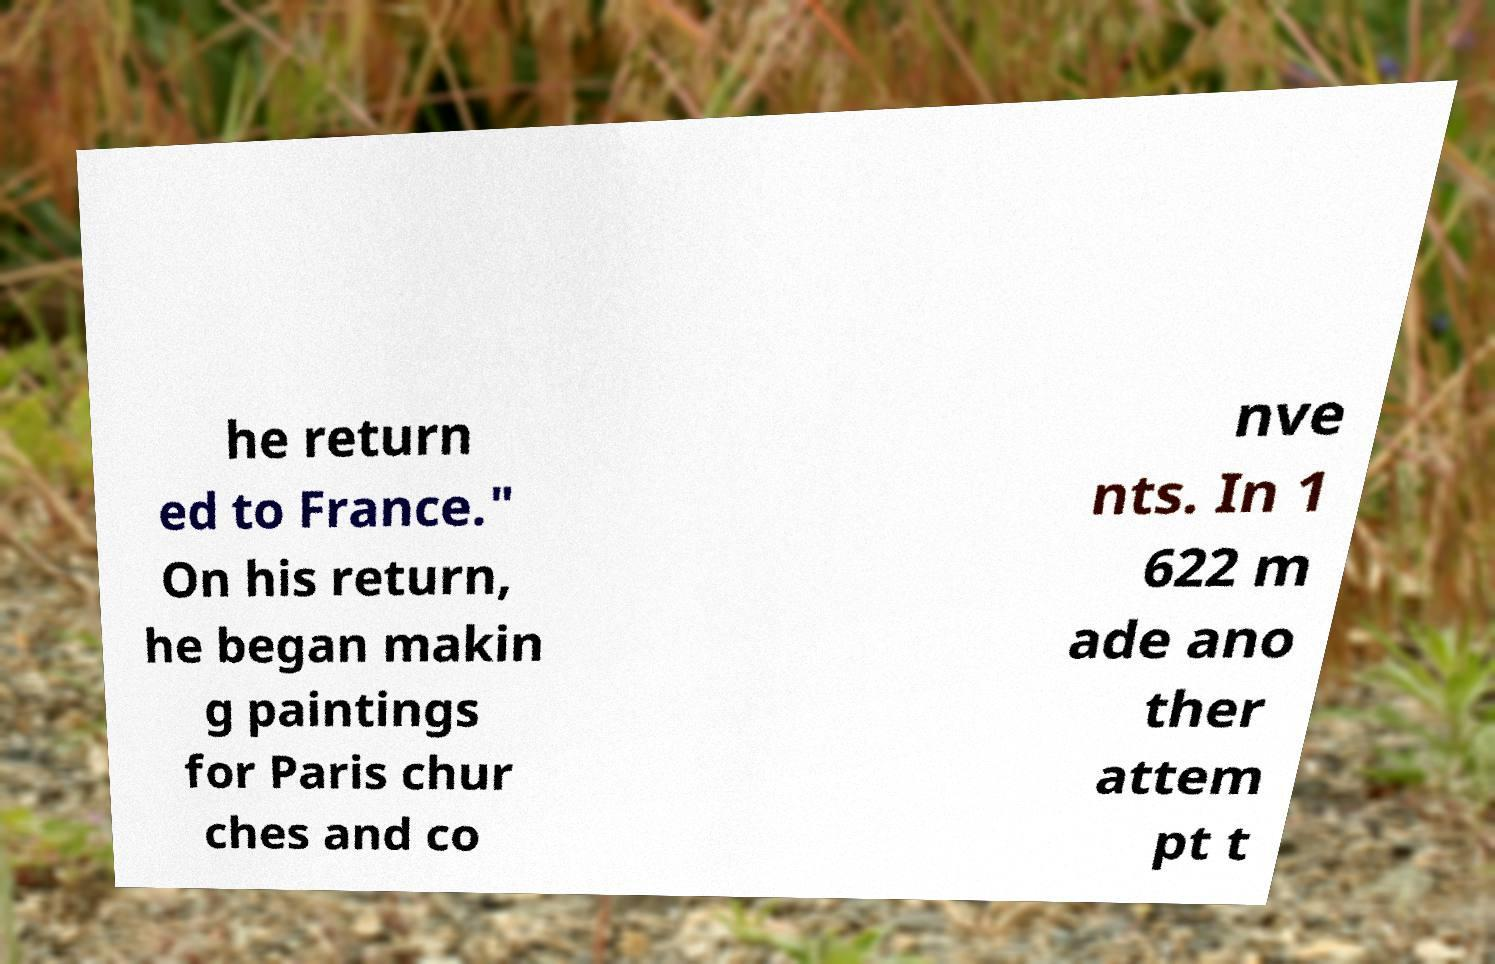I need the written content from this picture converted into text. Can you do that? he return ed to France." On his return, he began makin g paintings for Paris chur ches and co nve nts. In 1 622 m ade ano ther attem pt t 